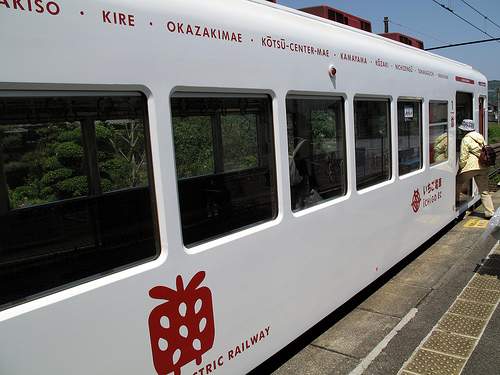<image>
Is the person to the left of the sidewalk? No. The person is not to the left of the sidewalk. From this viewpoint, they have a different horizontal relationship. Is there a bus next to the man? Yes. The bus is positioned adjacent to the man, located nearby in the same general area. 